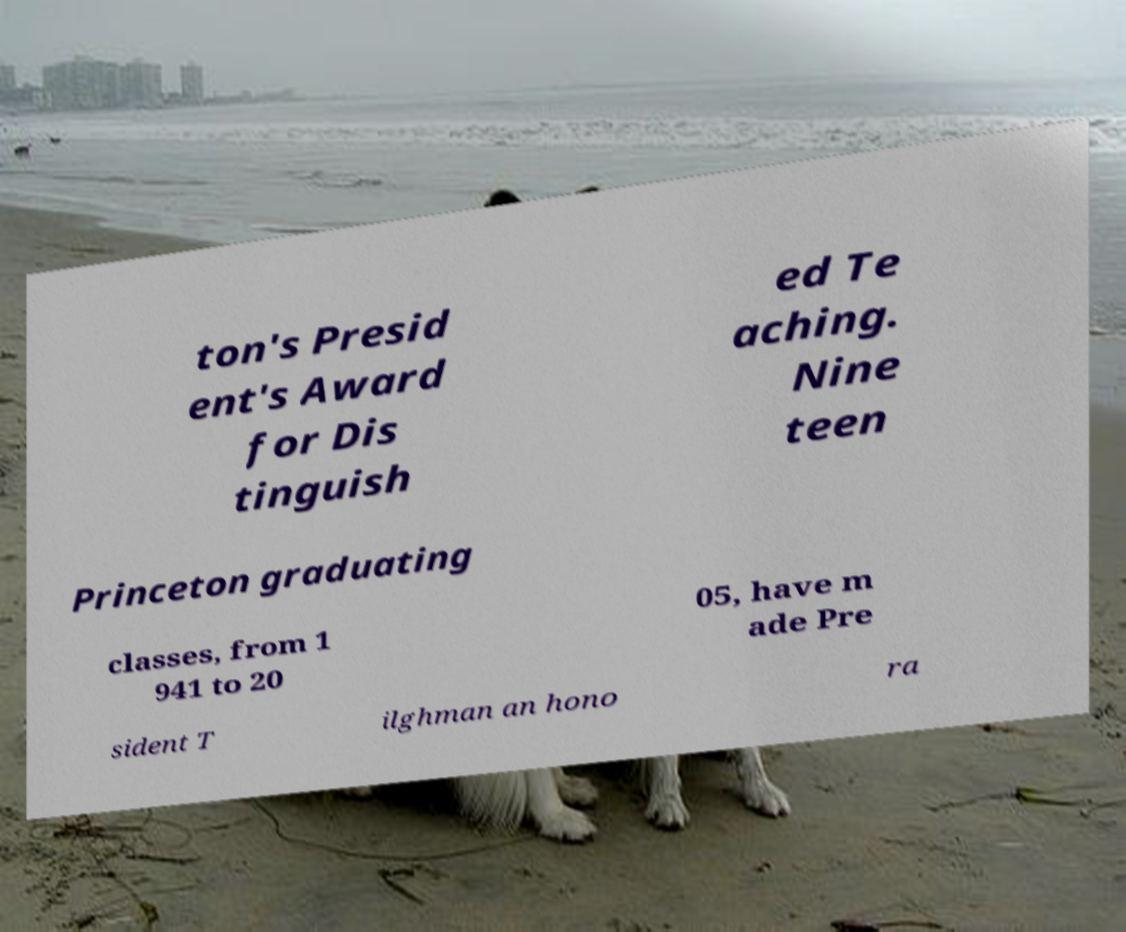Could you assist in decoding the text presented in this image and type it out clearly? ton's Presid ent's Award for Dis tinguish ed Te aching. Nine teen Princeton graduating classes, from 1 941 to 20 05, have m ade Pre sident T ilghman an hono ra 